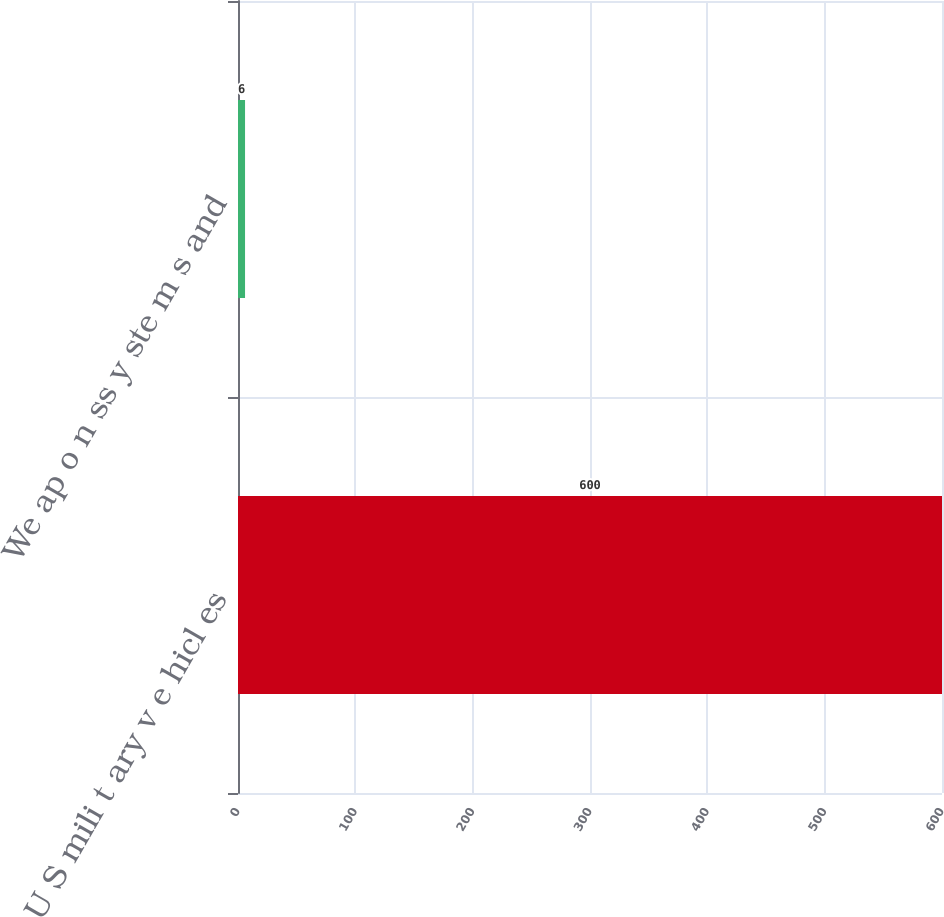Convert chart to OTSL. <chart><loc_0><loc_0><loc_500><loc_500><bar_chart><fcel>U S mili t ary v e hicl es<fcel>We ap o n ss y ste m s and<nl><fcel>600<fcel>6<nl></chart> 